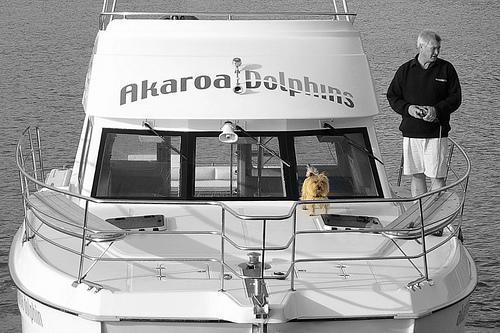How many people on the boat?
Give a very brief answer. 1. 